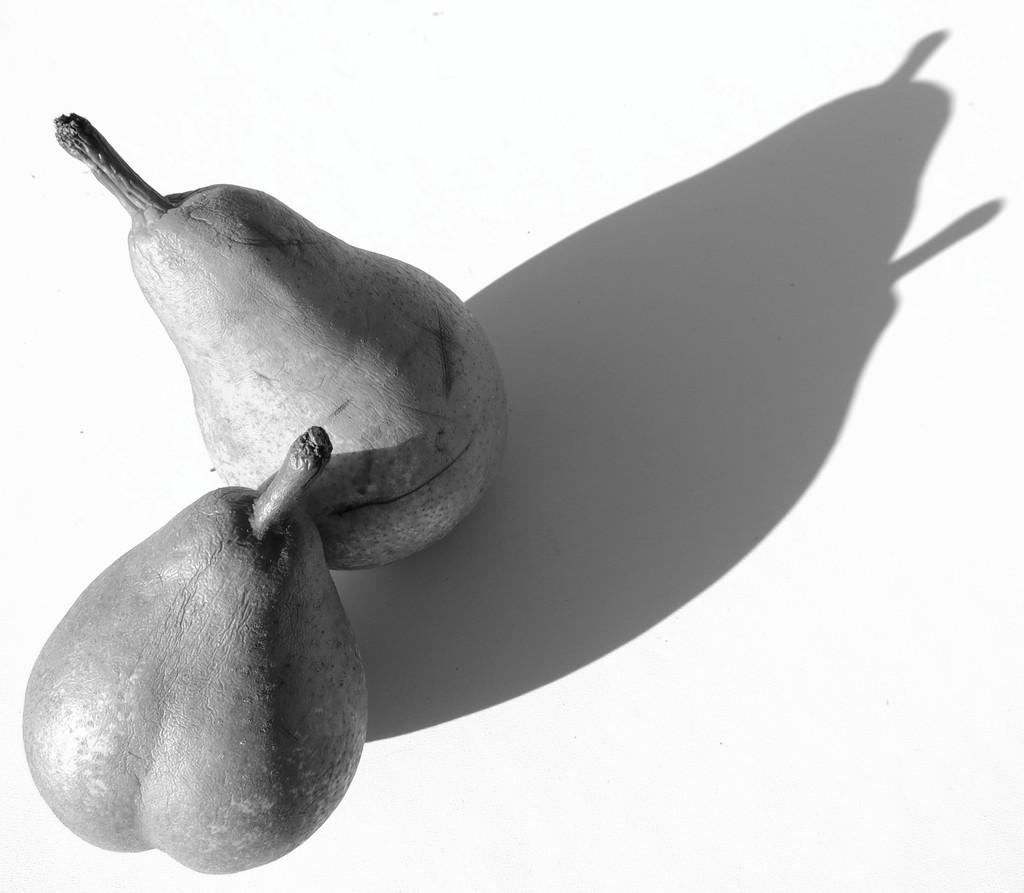How many fruits are present in the image? There are two fruits in the image. What else can be seen related to the fruits in the image? The shadow of the fruits is visible in the image. Can you see a plane flying over the fruits in the image? There is no plane visible in the image. Are there any men present in the image? There is no mention of men in the image. Is there a good-bye message written on the fruits in the image? There is no mention of any message, good-bye or otherwise, written on the fruits in the image. 